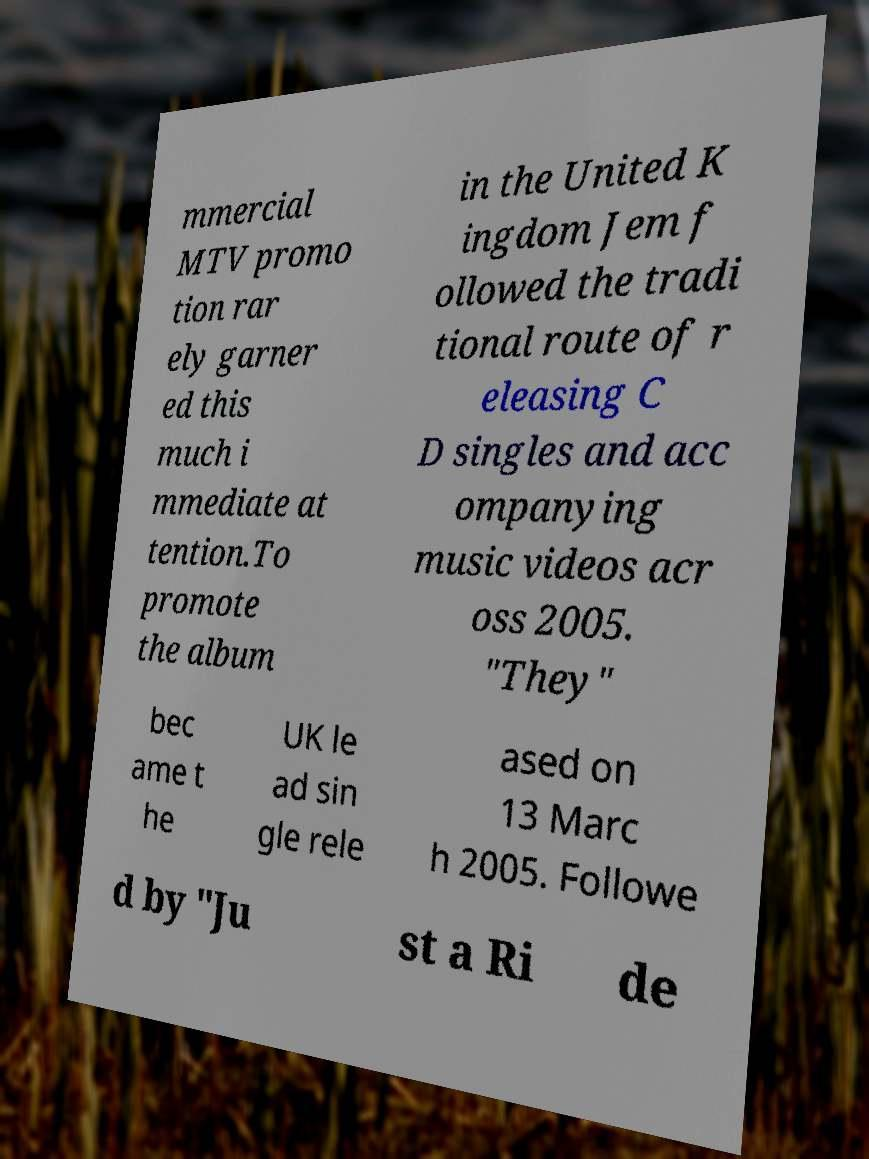What messages or text are displayed in this image? I need them in a readable, typed format. mmercial MTV promo tion rar ely garner ed this much i mmediate at tention.To promote the album in the United K ingdom Jem f ollowed the tradi tional route of r eleasing C D singles and acc ompanying music videos acr oss 2005. "They" bec ame t he UK le ad sin gle rele ased on 13 Marc h 2005. Followe d by "Ju st a Ri de 